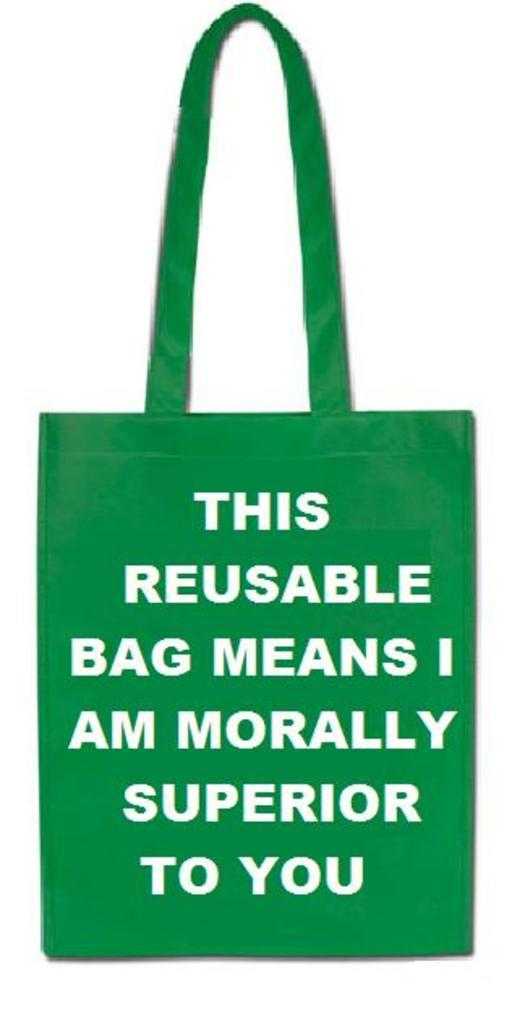What object is present in the picture? There is a bag in the picture. What color is the bag? The bag is green in color. What message is written on the bag? The text "this reusable bag means I am morally superior to you" is written on the bag. Is there a stream of water flowing through the bag in the image? No, there is no stream of water present in the image. 